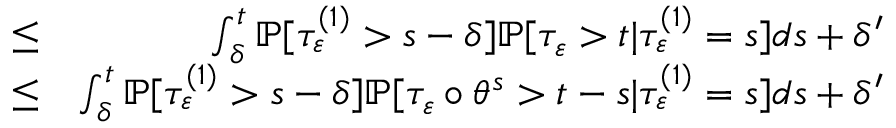Convert formula to latex. <formula><loc_0><loc_0><loc_500><loc_500>\begin{array} { r l r } & { \leq } & { \int _ { \delta } ^ { t } \mathbb { P } [ \tau _ { \varepsilon } ^ { ( 1 ) } > { s - \delta } ] \mathbb { P } [ \tau _ { \varepsilon } > t | \tau _ { \varepsilon } ^ { ( 1 ) } = s ] d s + \delta ^ { \prime } } \\ & { \leq } & { \int _ { \delta } ^ { t } \mathbb { P } [ \tau _ { \varepsilon } ^ { ( 1 ) } > { s - \delta } ] \mathbb { P } [ \tau _ { \varepsilon } \circ \theta ^ { s } > t - s | \tau _ { \varepsilon } ^ { ( 1 ) } = s ] d s + \delta ^ { \prime } } \end{array}</formula> 